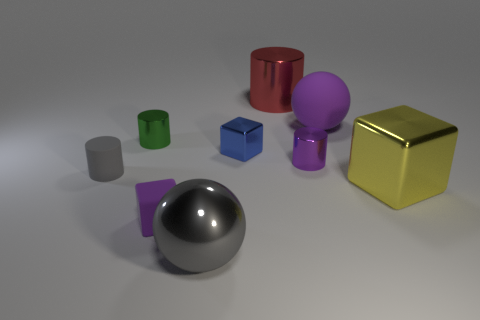Is there a large red metallic cylinder that is behind the small purple object that is left of the red cylinder?
Your response must be concise. Yes. There is a gray thing on the right side of the purple thing that is in front of the gray cylinder; what shape is it?
Offer a terse response. Sphere. Are there fewer big things than large metallic cubes?
Ensure brevity in your answer.  No. Does the green cylinder have the same material as the purple cylinder?
Give a very brief answer. Yes. The large object that is both in front of the blue metal thing and to the right of the big red thing is what color?
Make the answer very short. Yellow. Is there a yellow cylinder of the same size as the red cylinder?
Your answer should be very brief. No. There is a metallic block that is on the left side of the big shiny thing that is behind the big block; what is its size?
Provide a short and direct response. Small. Are there fewer red shiny cylinders to the right of the yellow thing than big cubes?
Make the answer very short. Yes. Do the rubber sphere and the small matte cube have the same color?
Offer a terse response. Yes. What size is the blue thing?
Your answer should be very brief. Small. 